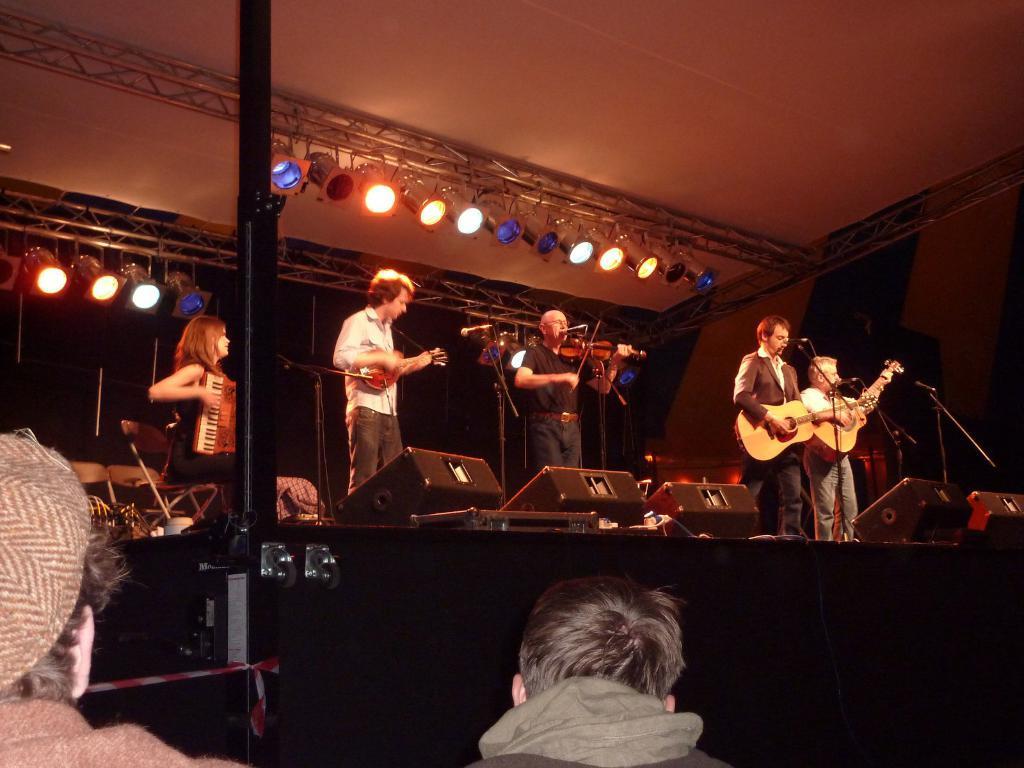Could you give a brief overview of what you see in this image? In this image we can see a group of persons are standing on the floor, and playing the musical instruments, and in front here is the microphone, and hear a woman is sitting and playing the piano, and at above here are the lights, and here are the people sitting. 